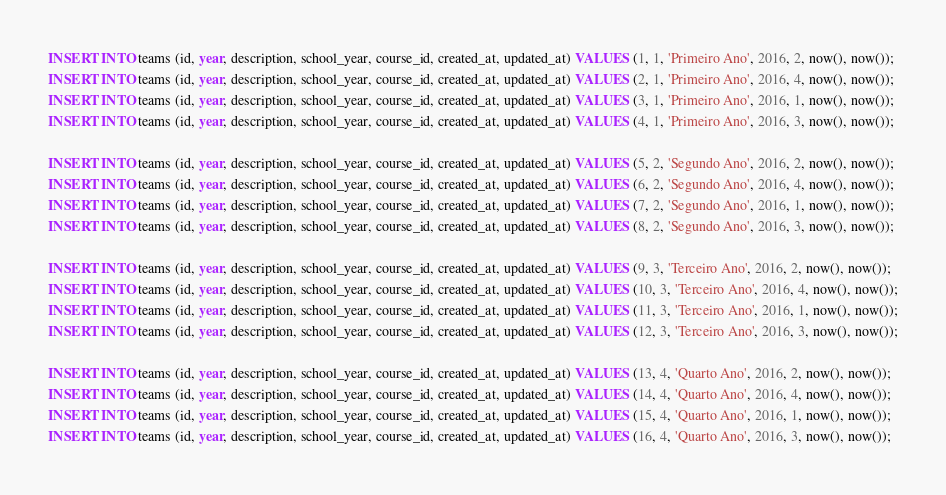Convert code to text. <code><loc_0><loc_0><loc_500><loc_500><_SQL_>INSERT INTO teams (id, year, description, school_year, course_id, created_at, updated_at) VALUES (1, 1, 'Primeiro Ano', 2016, 2, now(), now());
INSERT INTO teams (id, year, description, school_year, course_id, created_at, updated_at) VALUES (2, 1, 'Primeiro Ano', 2016, 4, now(), now());
INSERT INTO teams (id, year, description, school_year, course_id, created_at, updated_at) VALUES (3, 1, 'Primeiro Ano', 2016, 1, now(), now());
INSERT INTO teams (id, year, description, school_year, course_id, created_at, updated_at) VALUES (4, 1, 'Primeiro Ano', 2016, 3, now(), now());

INSERT INTO teams (id, year, description, school_year, course_id, created_at, updated_at) VALUES (5, 2, 'Segundo Ano', 2016, 2, now(), now());
INSERT INTO teams (id, year, description, school_year, course_id, created_at, updated_at) VALUES (6, 2, 'Segundo Ano', 2016, 4, now(), now());
INSERT INTO teams (id, year, description, school_year, course_id, created_at, updated_at) VALUES (7, 2, 'Segundo Ano', 2016, 1, now(), now());
INSERT INTO teams (id, year, description, school_year, course_id, created_at, updated_at) VALUES (8, 2, 'Segundo Ano', 2016, 3, now(), now());

INSERT INTO teams (id, year, description, school_year, course_id, created_at, updated_at) VALUES (9, 3, 'Terceiro Ano', 2016, 2, now(), now());
INSERT INTO teams (id, year, description, school_year, course_id, created_at, updated_at) VALUES (10, 3, 'Terceiro Ano', 2016, 4, now(), now());
INSERT INTO teams (id, year, description, school_year, course_id, created_at, updated_at) VALUES (11, 3, 'Terceiro Ano', 2016, 1, now(), now());
INSERT INTO teams (id, year, description, school_year, course_id, created_at, updated_at) VALUES (12, 3, 'Terceiro Ano', 2016, 3, now(), now());

INSERT INTO teams (id, year, description, school_year, course_id, created_at, updated_at) VALUES (13, 4, 'Quarto Ano', 2016, 2, now(), now());
INSERT INTO teams (id, year, description, school_year, course_id, created_at, updated_at) VALUES (14, 4, 'Quarto Ano', 2016, 4, now(), now());
INSERT INTO teams (id, year, description, school_year, course_id, created_at, updated_at) VALUES (15, 4, 'Quarto Ano', 2016, 1, now(), now());
INSERT INTO teams (id, year, description, school_year, course_id, created_at, updated_at) VALUES (16, 4, 'Quarto Ano', 2016, 3, now(), now());





</code> 